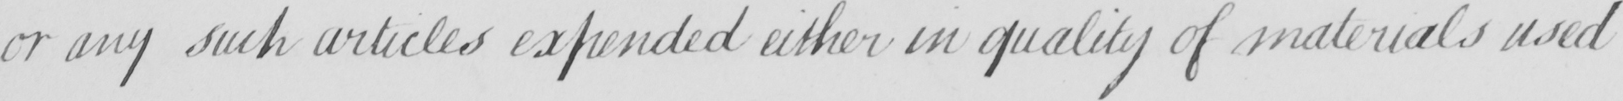Transcribe the text shown in this historical manuscript line. or any such articles expended either in quality of materials used 